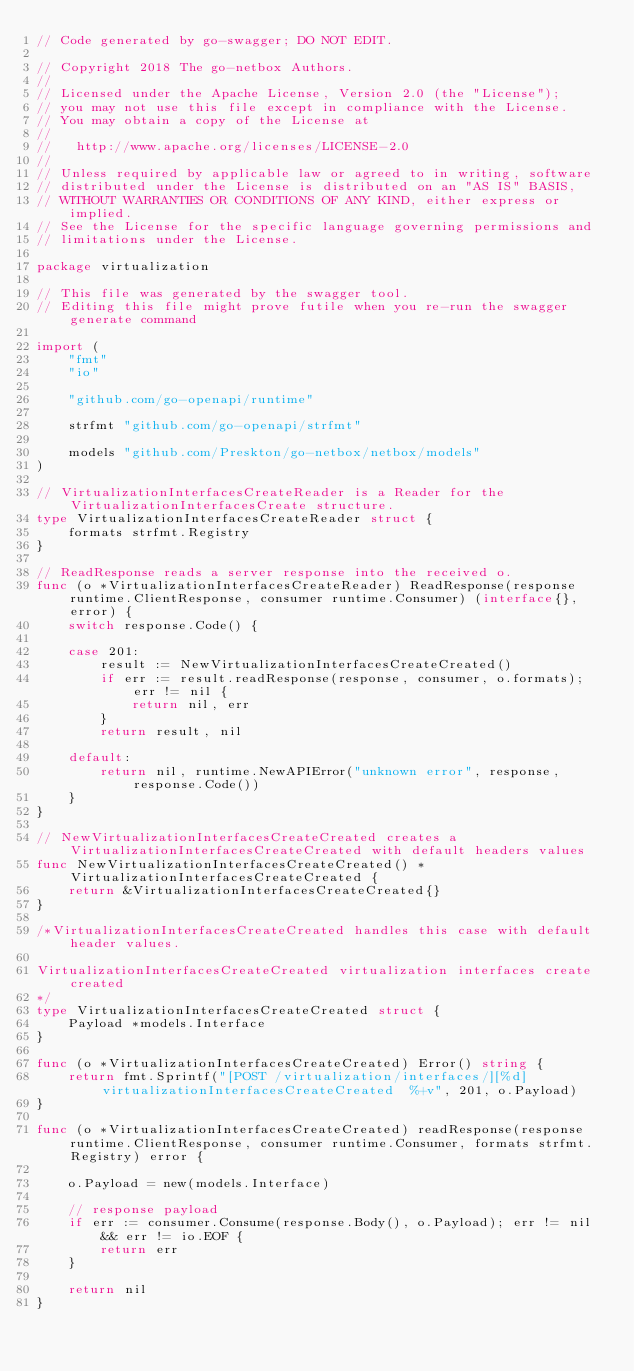Convert code to text. <code><loc_0><loc_0><loc_500><loc_500><_Go_>// Code generated by go-swagger; DO NOT EDIT.

// Copyright 2018 The go-netbox Authors.
//
// Licensed under the Apache License, Version 2.0 (the "License");
// you may not use this file except in compliance with the License.
// You may obtain a copy of the License at
//
//   http://www.apache.org/licenses/LICENSE-2.0
//
// Unless required by applicable law or agreed to in writing, software
// distributed under the License is distributed on an "AS IS" BASIS,
// WITHOUT WARRANTIES OR CONDITIONS OF ANY KIND, either express or implied.
// See the License for the specific language governing permissions and
// limitations under the License.

package virtualization

// This file was generated by the swagger tool.
// Editing this file might prove futile when you re-run the swagger generate command

import (
	"fmt"
	"io"

	"github.com/go-openapi/runtime"

	strfmt "github.com/go-openapi/strfmt"

	models "github.com/Preskton/go-netbox/netbox/models"
)

// VirtualizationInterfacesCreateReader is a Reader for the VirtualizationInterfacesCreate structure.
type VirtualizationInterfacesCreateReader struct {
	formats strfmt.Registry
}

// ReadResponse reads a server response into the received o.
func (o *VirtualizationInterfacesCreateReader) ReadResponse(response runtime.ClientResponse, consumer runtime.Consumer) (interface{}, error) {
	switch response.Code() {

	case 201:
		result := NewVirtualizationInterfacesCreateCreated()
		if err := result.readResponse(response, consumer, o.formats); err != nil {
			return nil, err
		}
		return result, nil

	default:
		return nil, runtime.NewAPIError("unknown error", response, response.Code())
	}
}

// NewVirtualizationInterfacesCreateCreated creates a VirtualizationInterfacesCreateCreated with default headers values
func NewVirtualizationInterfacesCreateCreated() *VirtualizationInterfacesCreateCreated {
	return &VirtualizationInterfacesCreateCreated{}
}

/*VirtualizationInterfacesCreateCreated handles this case with default header values.

VirtualizationInterfacesCreateCreated virtualization interfaces create created
*/
type VirtualizationInterfacesCreateCreated struct {
	Payload *models.Interface
}

func (o *VirtualizationInterfacesCreateCreated) Error() string {
	return fmt.Sprintf("[POST /virtualization/interfaces/][%d] virtualizationInterfacesCreateCreated  %+v", 201, o.Payload)
}

func (o *VirtualizationInterfacesCreateCreated) readResponse(response runtime.ClientResponse, consumer runtime.Consumer, formats strfmt.Registry) error {

	o.Payload = new(models.Interface)

	// response payload
	if err := consumer.Consume(response.Body(), o.Payload); err != nil && err != io.EOF {
		return err
	}

	return nil
}
</code> 